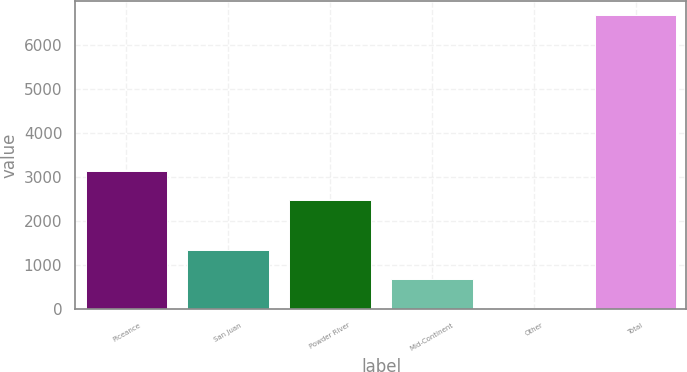Convert chart. <chart><loc_0><loc_0><loc_500><loc_500><bar_chart><fcel>Piceance<fcel>San Juan<fcel>Powder River<fcel>Mid-Continent<fcel>Other<fcel>Total<nl><fcel>3129.5<fcel>1350<fcel>2465<fcel>685.5<fcel>21<fcel>6666<nl></chart> 